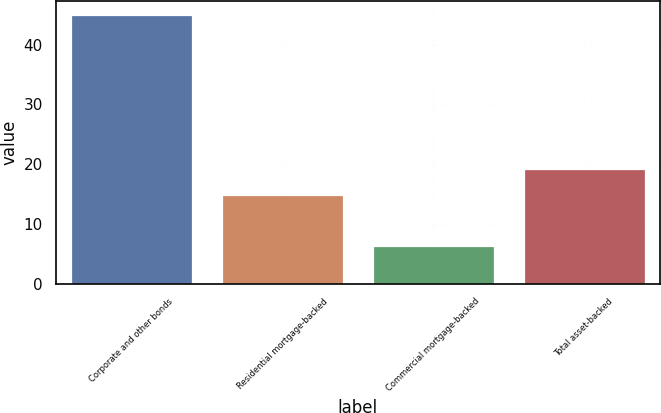<chart> <loc_0><loc_0><loc_500><loc_500><bar_chart><fcel>Corporate and other bonds<fcel>Residential mortgage-backed<fcel>Commercial mortgage-backed<fcel>Total asset-backed<nl><fcel>45<fcel>14.9<fcel>6.3<fcel>19.2<nl></chart> 